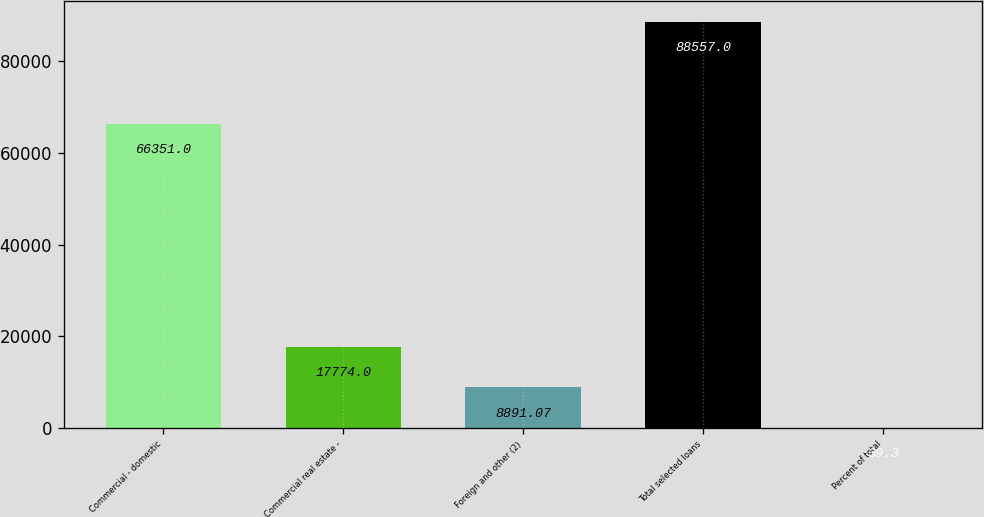Convert chart to OTSL. <chart><loc_0><loc_0><loc_500><loc_500><bar_chart><fcel>Commercial - domestic<fcel>Commercial real estate -<fcel>Foreign and other (2)<fcel>Total selected loans<fcel>Percent of total<nl><fcel>66351<fcel>17774<fcel>8891.07<fcel>88557<fcel>39.3<nl></chart> 